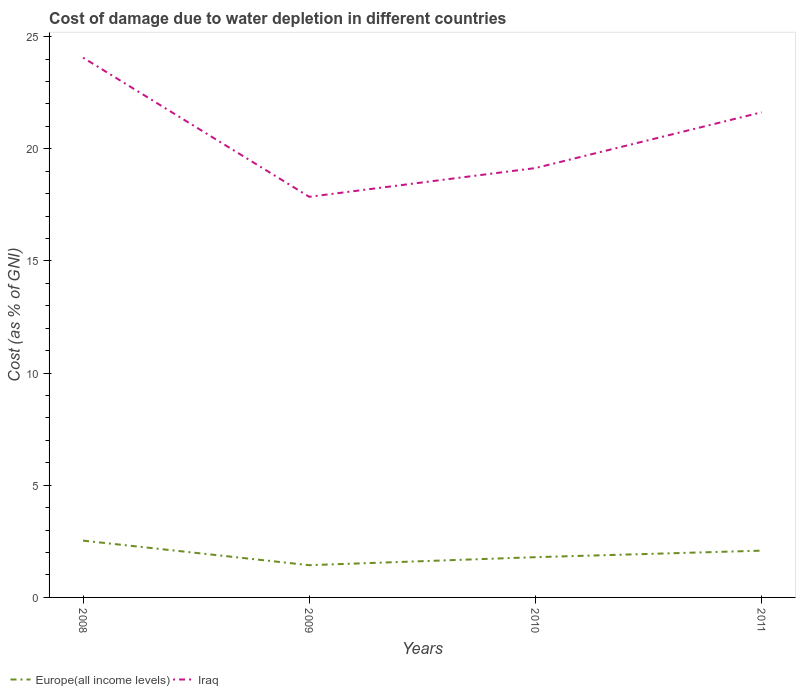Does the line corresponding to Europe(all income levels) intersect with the line corresponding to Iraq?
Give a very brief answer. No. Is the number of lines equal to the number of legend labels?
Provide a succinct answer. Yes. Across all years, what is the maximum cost of damage caused due to water depletion in Europe(all income levels)?
Keep it short and to the point. 1.44. In which year was the cost of damage caused due to water depletion in Iraq maximum?
Give a very brief answer. 2009. What is the total cost of damage caused due to water depletion in Iraq in the graph?
Give a very brief answer. -3.77. What is the difference between the highest and the second highest cost of damage caused due to water depletion in Iraq?
Your answer should be very brief. 6.2. What is the difference between the highest and the lowest cost of damage caused due to water depletion in Iraq?
Give a very brief answer. 2. How many lines are there?
Offer a very short reply. 2. Does the graph contain any zero values?
Offer a terse response. No. Does the graph contain grids?
Your answer should be very brief. No. Where does the legend appear in the graph?
Make the answer very short. Bottom left. How many legend labels are there?
Your answer should be compact. 2. What is the title of the graph?
Your answer should be compact. Cost of damage due to water depletion in different countries. Does "Nepal" appear as one of the legend labels in the graph?
Make the answer very short. No. What is the label or title of the Y-axis?
Your answer should be compact. Cost (as % of GNI). What is the Cost (as % of GNI) in Europe(all income levels) in 2008?
Give a very brief answer. 2.53. What is the Cost (as % of GNI) of Iraq in 2008?
Provide a succinct answer. 24.07. What is the Cost (as % of GNI) of Europe(all income levels) in 2009?
Provide a succinct answer. 1.44. What is the Cost (as % of GNI) in Iraq in 2009?
Give a very brief answer. 17.86. What is the Cost (as % of GNI) in Europe(all income levels) in 2010?
Provide a short and direct response. 1.79. What is the Cost (as % of GNI) in Iraq in 2010?
Offer a terse response. 19.14. What is the Cost (as % of GNI) of Europe(all income levels) in 2011?
Keep it short and to the point. 2.08. What is the Cost (as % of GNI) of Iraq in 2011?
Your answer should be compact. 21.63. Across all years, what is the maximum Cost (as % of GNI) of Europe(all income levels)?
Provide a short and direct response. 2.53. Across all years, what is the maximum Cost (as % of GNI) of Iraq?
Provide a short and direct response. 24.07. Across all years, what is the minimum Cost (as % of GNI) in Europe(all income levels)?
Give a very brief answer. 1.44. Across all years, what is the minimum Cost (as % of GNI) in Iraq?
Provide a short and direct response. 17.86. What is the total Cost (as % of GNI) in Europe(all income levels) in the graph?
Provide a short and direct response. 7.85. What is the total Cost (as % of GNI) in Iraq in the graph?
Offer a terse response. 82.7. What is the difference between the Cost (as % of GNI) of Europe(all income levels) in 2008 and that in 2009?
Your answer should be very brief. 1.09. What is the difference between the Cost (as % of GNI) in Iraq in 2008 and that in 2009?
Ensure brevity in your answer.  6.2. What is the difference between the Cost (as % of GNI) of Europe(all income levels) in 2008 and that in 2010?
Provide a succinct answer. 0.74. What is the difference between the Cost (as % of GNI) of Iraq in 2008 and that in 2010?
Your answer should be compact. 4.92. What is the difference between the Cost (as % of GNI) of Europe(all income levels) in 2008 and that in 2011?
Your response must be concise. 0.45. What is the difference between the Cost (as % of GNI) of Iraq in 2008 and that in 2011?
Your response must be concise. 2.44. What is the difference between the Cost (as % of GNI) of Europe(all income levels) in 2009 and that in 2010?
Provide a succinct answer. -0.36. What is the difference between the Cost (as % of GNI) in Iraq in 2009 and that in 2010?
Ensure brevity in your answer.  -1.28. What is the difference between the Cost (as % of GNI) in Europe(all income levels) in 2009 and that in 2011?
Give a very brief answer. -0.65. What is the difference between the Cost (as % of GNI) of Iraq in 2009 and that in 2011?
Provide a short and direct response. -3.77. What is the difference between the Cost (as % of GNI) of Europe(all income levels) in 2010 and that in 2011?
Your answer should be compact. -0.29. What is the difference between the Cost (as % of GNI) of Iraq in 2010 and that in 2011?
Your response must be concise. -2.49. What is the difference between the Cost (as % of GNI) in Europe(all income levels) in 2008 and the Cost (as % of GNI) in Iraq in 2009?
Your response must be concise. -15.33. What is the difference between the Cost (as % of GNI) in Europe(all income levels) in 2008 and the Cost (as % of GNI) in Iraq in 2010?
Offer a very short reply. -16.61. What is the difference between the Cost (as % of GNI) in Europe(all income levels) in 2008 and the Cost (as % of GNI) in Iraq in 2011?
Offer a terse response. -19.1. What is the difference between the Cost (as % of GNI) of Europe(all income levels) in 2009 and the Cost (as % of GNI) of Iraq in 2010?
Your answer should be compact. -17.7. What is the difference between the Cost (as % of GNI) of Europe(all income levels) in 2009 and the Cost (as % of GNI) of Iraq in 2011?
Your answer should be compact. -20.19. What is the difference between the Cost (as % of GNI) of Europe(all income levels) in 2010 and the Cost (as % of GNI) of Iraq in 2011?
Give a very brief answer. -19.83. What is the average Cost (as % of GNI) in Europe(all income levels) per year?
Your answer should be compact. 1.96. What is the average Cost (as % of GNI) of Iraq per year?
Make the answer very short. 20.67. In the year 2008, what is the difference between the Cost (as % of GNI) in Europe(all income levels) and Cost (as % of GNI) in Iraq?
Give a very brief answer. -21.53. In the year 2009, what is the difference between the Cost (as % of GNI) of Europe(all income levels) and Cost (as % of GNI) of Iraq?
Offer a terse response. -16.42. In the year 2010, what is the difference between the Cost (as % of GNI) in Europe(all income levels) and Cost (as % of GNI) in Iraq?
Give a very brief answer. -17.35. In the year 2011, what is the difference between the Cost (as % of GNI) in Europe(all income levels) and Cost (as % of GNI) in Iraq?
Your answer should be very brief. -19.54. What is the ratio of the Cost (as % of GNI) in Europe(all income levels) in 2008 to that in 2009?
Offer a very short reply. 1.76. What is the ratio of the Cost (as % of GNI) in Iraq in 2008 to that in 2009?
Give a very brief answer. 1.35. What is the ratio of the Cost (as % of GNI) in Europe(all income levels) in 2008 to that in 2010?
Keep it short and to the point. 1.41. What is the ratio of the Cost (as % of GNI) in Iraq in 2008 to that in 2010?
Provide a short and direct response. 1.26. What is the ratio of the Cost (as % of GNI) of Europe(all income levels) in 2008 to that in 2011?
Keep it short and to the point. 1.21. What is the ratio of the Cost (as % of GNI) in Iraq in 2008 to that in 2011?
Keep it short and to the point. 1.11. What is the ratio of the Cost (as % of GNI) in Europe(all income levels) in 2009 to that in 2010?
Make the answer very short. 0.8. What is the ratio of the Cost (as % of GNI) of Iraq in 2009 to that in 2010?
Give a very brief answer. 0.93. What is the ratio of the Cost (as % of GNI) of Europe(all income levels) in 2009 to that in 2011?
Your response must be concise. 0.69. What is the ratio of the Cost (as % of GNI) of Iraq in 2009 to that in 2011?
Provide a succinct answer. 0.83. What is the ratio of the Cost (as % of GNI) of Europe(all income levels) in 2010 to that in 2011?
Offer a terse response. 0.86. What is the ratio of the Cost (as % of GNI) in Iraq in 2010 to that in 2011?
Ensure brevity in your answer.  0.89. What is the difference between the highest and the second highest Cost (as % of GNI) of Europe(all income levels)?
Make the answer very short. 0.45. What is the difference between the highest and the second highest Cost (as % of GNI) of Iraq?
Your answer should be compact. 2.44. What is the difference between the highest and the lowest Cost (as % of GNI) in Europe(all income levels)?
Offer a very short reply. 1.09. What is the difference between the highest and the lowest Cost (as % of GNI) in Iraq?
Make the answer very short. 6.2. 